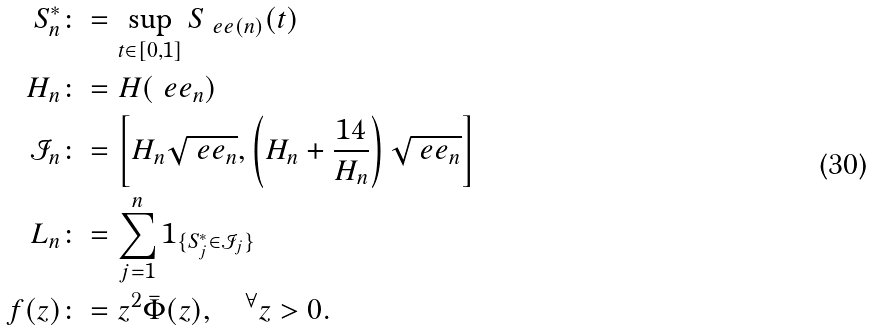Convert formula to latex. <formula><loc_0><loc_0><loc_500><loc_500>S ^ { * } _ { n } & \colon = \sup _ { t \in [ 0 , 1 ] } S _ { \ e e ( n ) } ( t ) \\ H _ { n } & \colon = H ( \ e e _ { n } ) \\ \mathcal { I } _ { n } & \colon = \left [ H _ { n } \sqrt { \ e e _ { n } } , \left ( H _ { n } + \frac { 1 4 } { H _ { n } } \right ) \sqrt { \ e e _ { n } } \right ] \\ L _ { n } & \colon = \sum _ { j = 1 } ^ { n } 1 _ { \{ S ^ { * } _ { j } \in \mathcal { I } _ { j } \} } \\ f ( z ) & \colon = z ^ { 2 } \bar { \Phi } ( z ) , \quad ^ { \forall } z > 0 .</formula> 